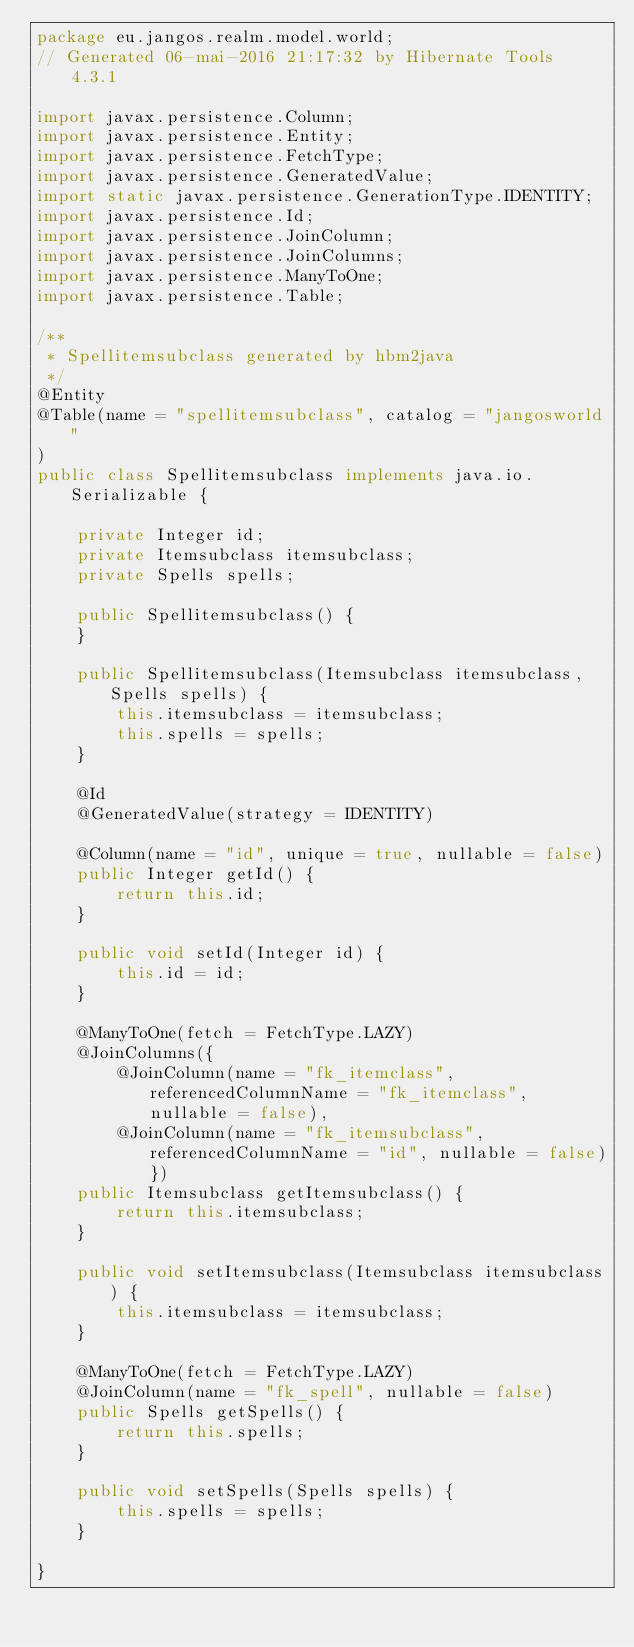Convert code to text. <code><loc_0><loc_0><loc_500><loc_500><_Java_>package eu.jangos.realm.model.world;
// Generated 06-mai-2016 21:17:32 by Hibernate Tools 4.3.1

import javax.persistence.Column;
import javax.persistence.Entity;
import javax.persistence.FetchType;
import javax.persistence.GeneratedValue;
import static javax.persistence.GenerationType.IDENTITY;
import javax.persistence.Id;
import javax.persistence.JoinColumn;
import javax.persistence.JoinColumns;
import javax.persistence.ManyToOne;
import javax.persistence.Table;

/**
 * Spellitemsubclass generated by hbm2java
 */
@Entity
@Table(name = "spellitemsubclass", catalog = "jangosworld"
)
public class Spellitemsubclass implements java.io.Serializable {

    private Integer id;
    private Itemsubclass itemsubclass;
    private Spells spells;

    public Spellitemsubclass() {
    }

    public Spellitemsubclass(Itemsubclass itemsubclass, Spells spells) {
        this.itemsubclass = itemsubclass;
        this.spells = spells;
    }

    @Id
    @GeneratedValue(strategy = IDENTITY)

    @Column(name = "id", unique = true, nullable = false)
    public Integer getId() {
        return this.id;
    }

    public void setId(Integer id) {
        this.id = id;
    }

    @ManyToOne(fetch = FetchType.LAZY)
    @JoinColumns({
        @JoinColumn(name = "fk_itemclass", referencedColumnName = "fk_itemclass", nullable = false),
        @JoinColumn(name = "fk_itemsubclass", referencedColumnName = "id", nullable = false)})
    public Itemsubclass getItemsubclass() {
        return this.itemsubclass;
    }

    public void setItemsubclass(Itemsubclass itemsubclass) {
        this.itemsubclass = itemsubclass;
    }

    @ManyToOne(fetch = FetchType.LAZY)
    @JoinColumn(name = "fk_spell", nullable = false)
    public Spells getSpells() {
        return this.spells;
    }

    public void setSpells(Spells spells) {
        this.spells = spells;
    }

}
</code> 